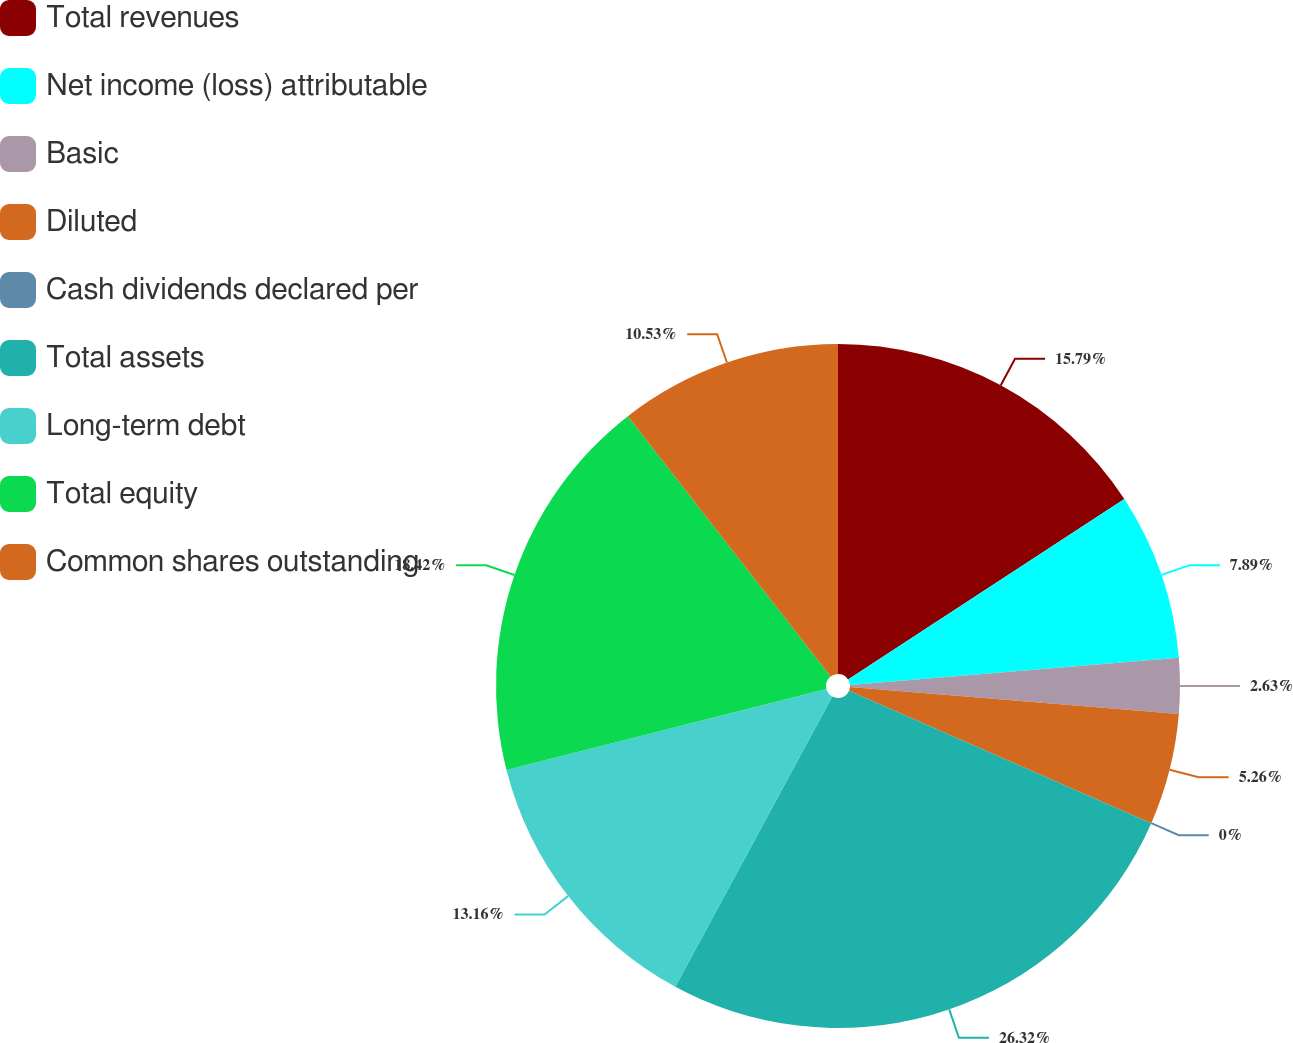Convert chart to OTSL. <chart><loc_0><loc_0><loc_500><loc_500><pie_chart><fcel>Total revenues<fcel>Net income (loss) attributable<fcel>Basic<fcel>Diluted<fcel>Cash dividends declared per<fcel>Total assets<fcel>Long-term debt<fcel>Total equity<fcel>Common shares outstanding<nl><fcel>15.79%<fcel>7.89%<fcel>2.63%<fcel>5.26%<fcel>0.0%<fcel>26.32%<fcel>13.16%<fcel>18.42%<fcel>10.53%<nl></chart> 